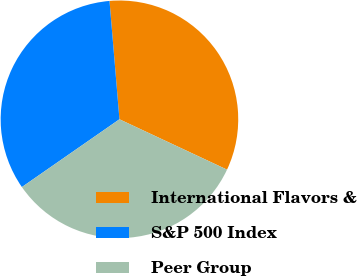Convert chart to OTSL. <chart><loc_0><loc_0><loc_500><loc_500><pie_chart><fcel>International Flavors &<fcel>S&P 500 Index<fcel>Peer Group<nl><fcel>33.3%<fcel>33.33%<fcel>33.37%<nl></chart> 